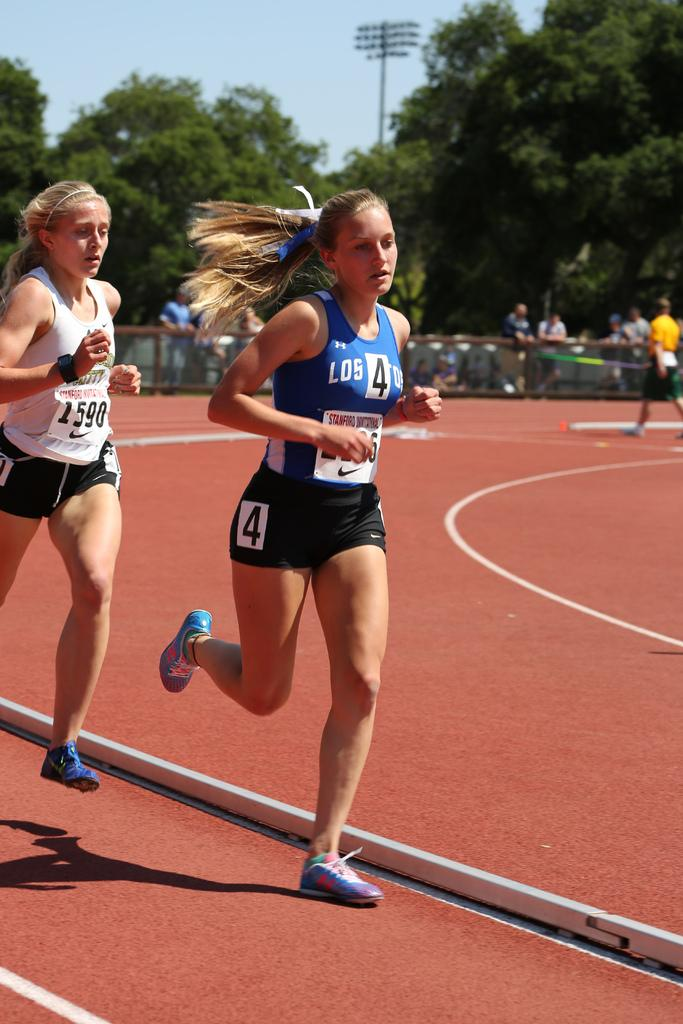<image>
Describe the image concisely. Two women running on a track with one the number four. 